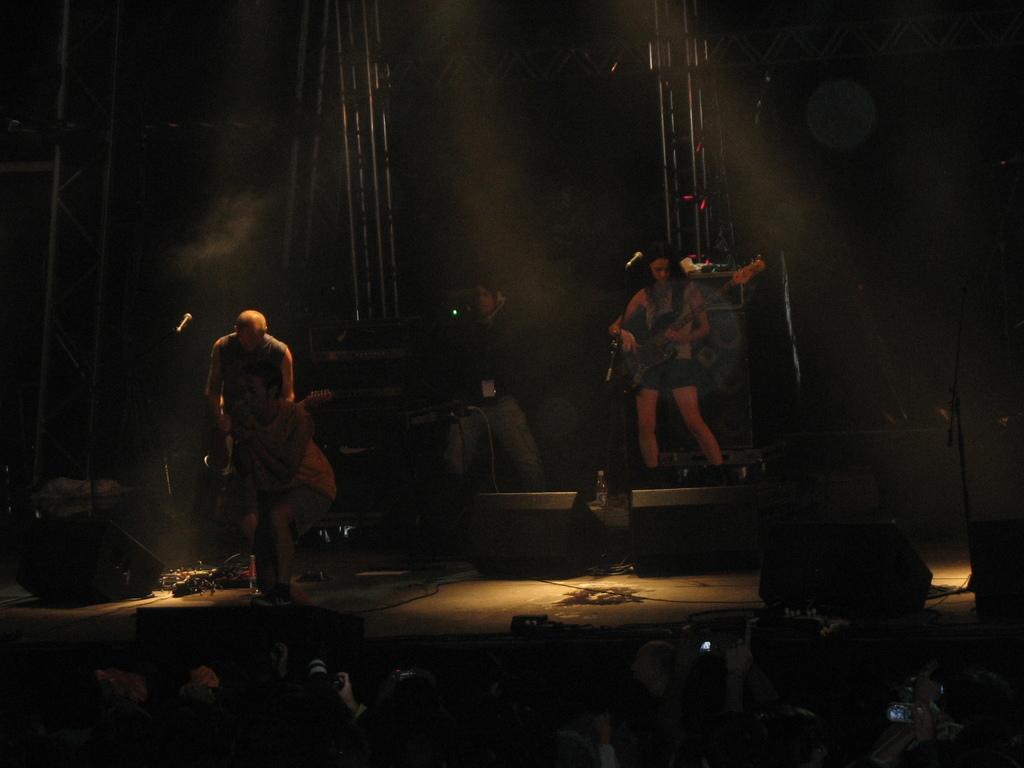In one or two sentences, can you explain what this image depicts? In this image there are group of people some of them are holding musical instruments and playing, and they are on the stage and we could see some lighting and fog and there are some poles. At the bottom there are a group of people, who are holding cameras and we could see some likes and there is a black background. 